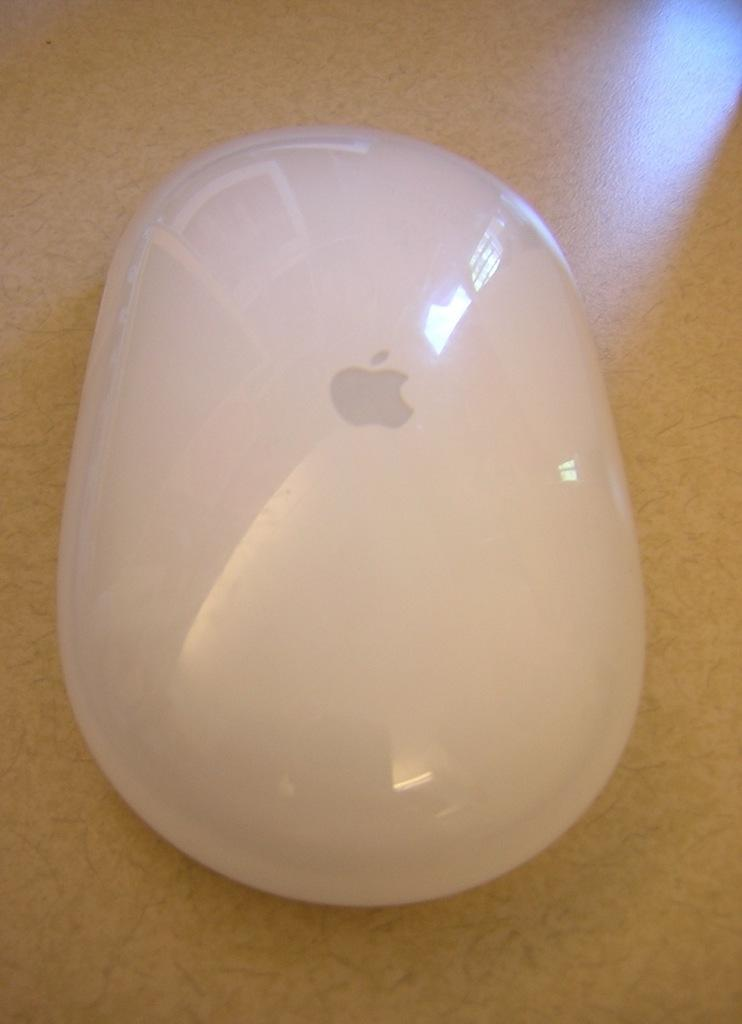What type of animal is in the image? There is a mouse in the image. What color is the mouse? The mouse is white in color. Where is the mouse located? The mouse is on a table. What material is the table made of? The table is made of wood. Is the mouse wearing a scarf in the image? No, the mouse is not wearing a scarf in the image. Can you see the moon in the image? No, the moon is not present in the image. 